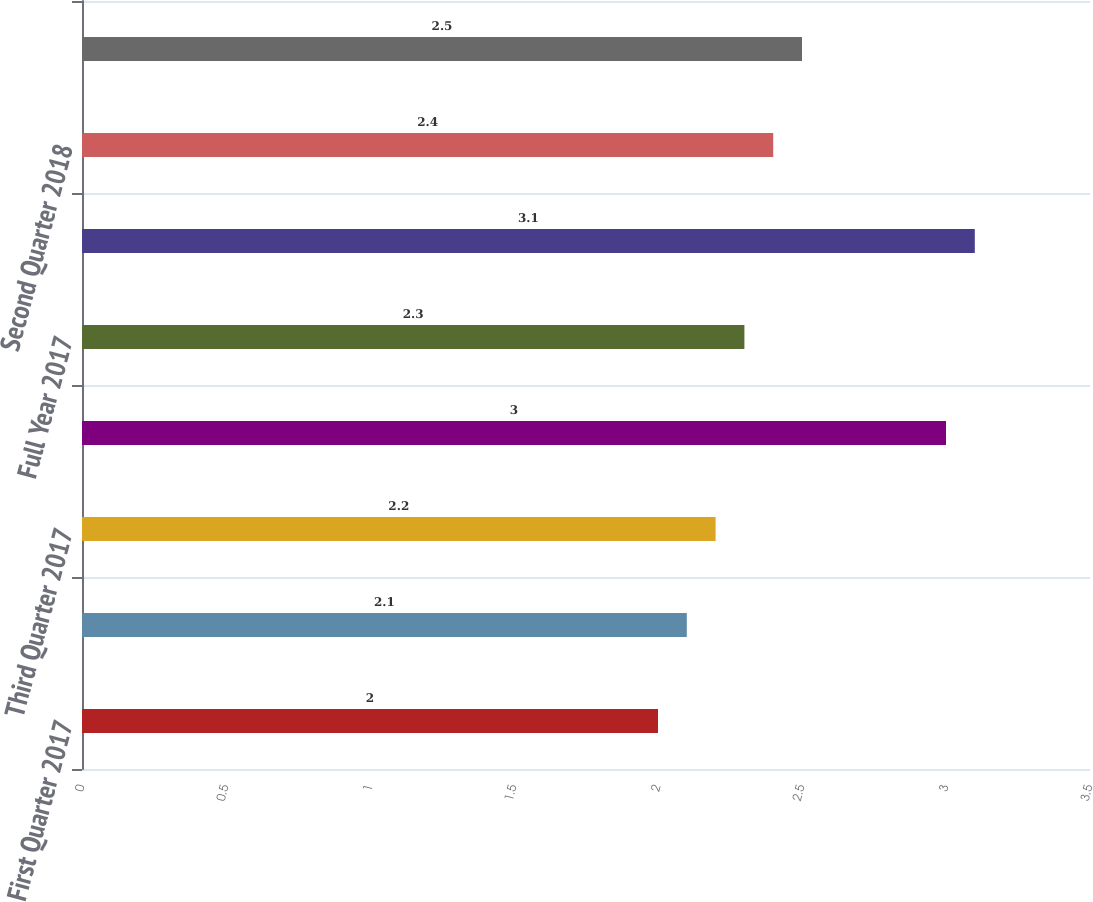Convert chart. <chart><loc_0><loc_0><loc_500><loc_500><bar_chart><fcel>First Quarter 2017<fcel>Second Quarter 2017<fcel>Third Quarter 2017<fcel>Fourth Quarter 2017<fcel>Full Year 2017<fcel>First Quarter 2018<fcel>Second Quarter 2018<fcel>Full Year 2018<nl><fcel>2<fcel>2.1<fcel>2.2<fcel>3<fcel>2.3<fcel>3.1<fcel>2.4<fcel>2.5<nl></chart> 